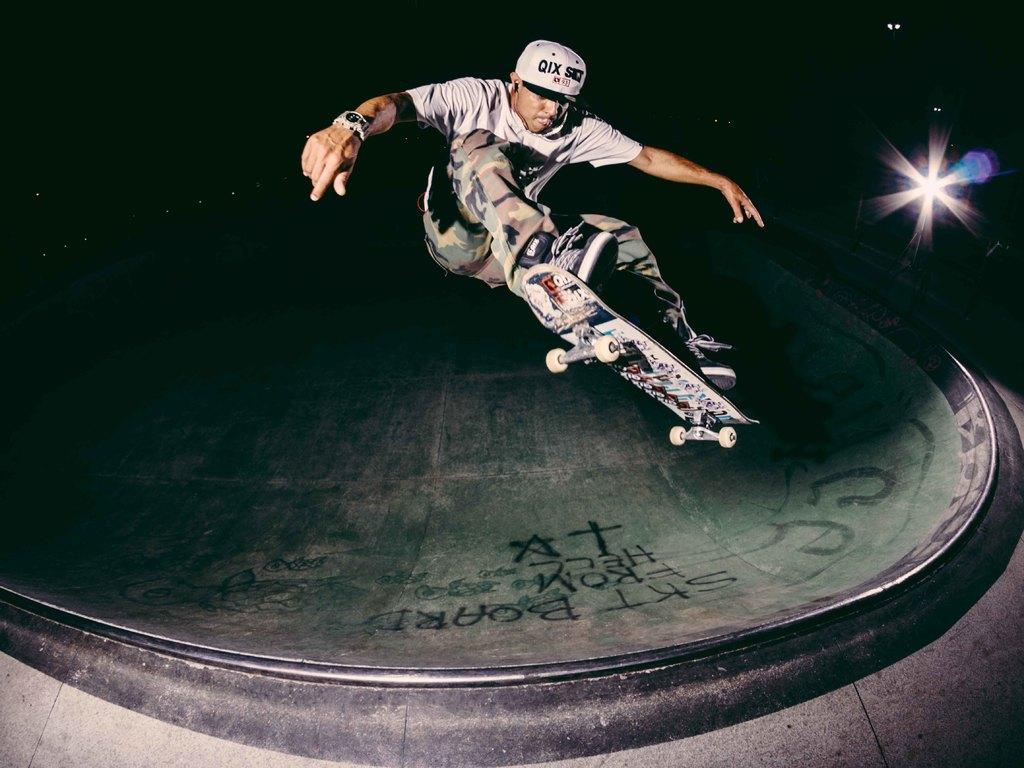Can you describe this image briefly? This is the man jumping along with the skateboard. He wore a cap, T-shirt, wrist watch, trouser and shoes. I think this is a skate park. This looks like a light. The background looks dark. 